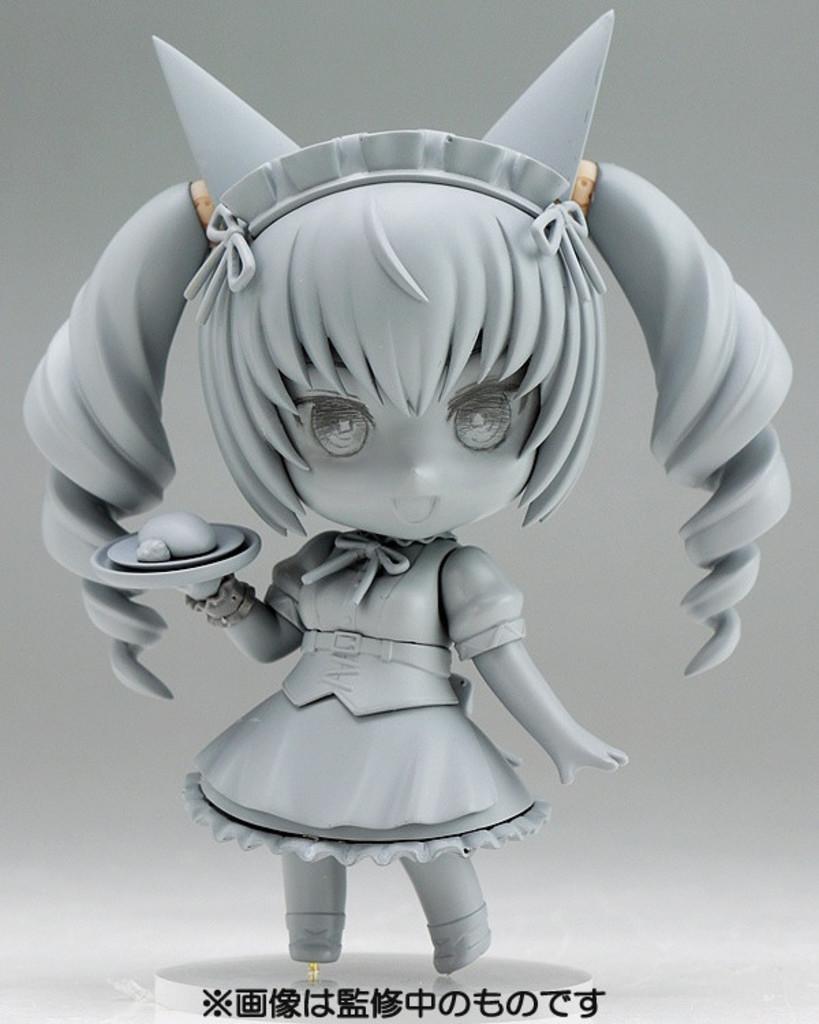In one or two sentences, can you explain what this image depicts? In this image in the middle there is a toy. At the bottom there is a text. This is an animated image. 